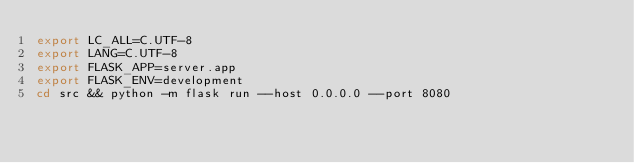<code> <loc_0><loc_0><loc_500><loc_500><_Bash_>export LC_ALL=C.UTF-8
export LANG=C.UTF-8
export FLASK_APP=server.app
export FLASK_ENV=development
cd src && python -m flask run --host 0.0.0.0 --port 8080</code> 